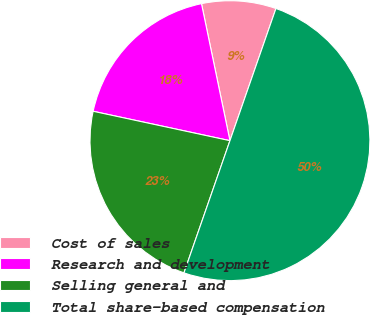Convert chart to OTSL. <chart><loc_0><loc_0><loc_500><loc_500><pie_chart><fcel>Cost of sales<fcel>Research and development<fcel>Selling general and<fcel>Total share-based compensation<nl><fcel>8.59%<fcel>18.37%<fcel>23.04%<fcel>50.0%<nl></chart> 